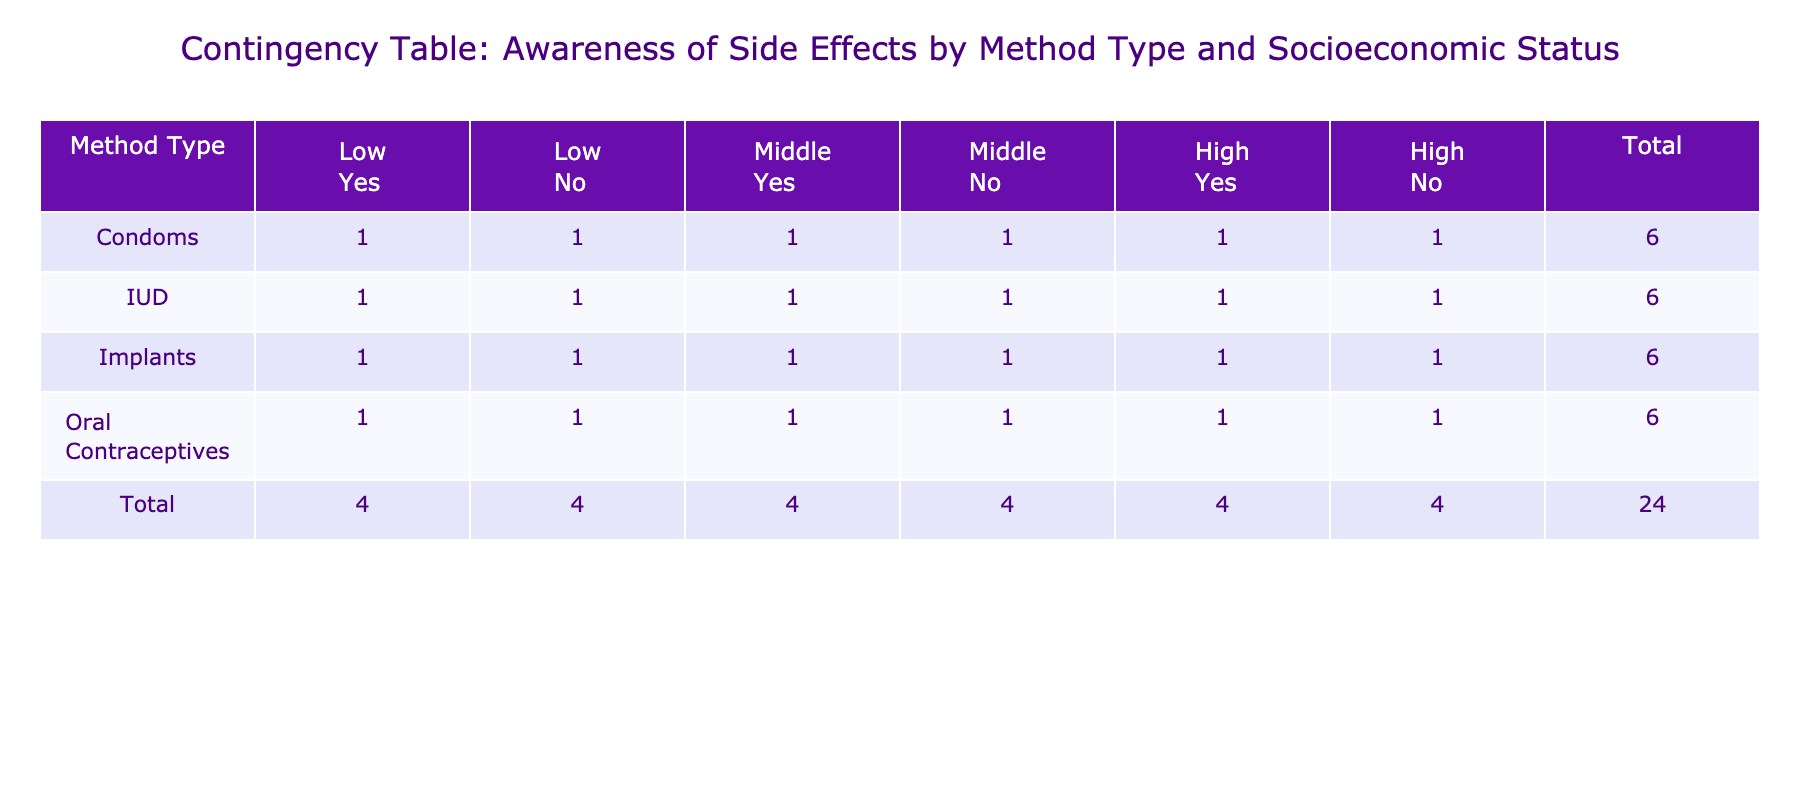What is the total awareness of side effects for Oral Contraceptives among individuals of high socioeconomic status? From the table, we look at the row for 'Oral Contraceptives' and the column 'High' under 'Awareness of Side Effects'. There are 1 person aware of the side effects (Yes) and 1 person not aware (No), so the total awareness (Yes) is 1.
Answer: 1 Which contraception method has the highest number of people aware of the side effects among low socioeconomic status? In the 'Low' socioeconomic status section, we examine the awareness columns for all methods. For 'Oral Contraceptives', 1 is aware; for 'Condoms', also 1 is aware; for 'IUD', 1 person is aware; and for 'Implants', 1 person is aware. All methods have the same total, so they are tied for the highest awareness.
Answer: All methods are tied What is the proportion of people unaware of side effects for Condoms among individuals of middle socioeconomic status? In the middle socioeconomic status for 'Condoms', there is 1 person aware and 1 person unaware of side effects. Total individuals in this category are 2 (1 Yes + 1 No). The proportion is 1 (unaware) divided by 2 (total) which gives us 0.5 or 50%
Answer: 50% How many people in total are aware of side effects for IUD across all socioeconomic statuses? We examine the 'IUD' row. The totals for 'Yes' awareness across all statuses are: 1 (Low Yes) + 1 (Middle Yes) + 1 (High Yes), adding these gives a total of 3 people aware of the side effects for IUD across all socioeconomic statuses.
Answer: 3 Are people of high socioeconomic status more likely to be aware of side effects compared to low socioeconomic status for Implants? For 'Implants', in high socioeconomic status, 1 is aware and 1 is not, totaling 2. In the low socioeconomic status, the situation is the same, with 1 aware and 1 not aware, totaling 2. Therefore, there is no difference in awareness between high and low socioeconomic statuses for Implants.
Answer: No, they have equal awareness What is the total count of individuals using oral contraceptives who are unaware of side effects across all socioeconomic statuses? We analyze the 'Oral Contraceptives' row for the 'No' column. The counts are 1 (Low No), 1 (Middle No), and 1 (High No). Adding these values gives us 3 individuals who are unaware of side effects for oral contraceptives across all statuses.
Answer: 3 How many people in total are there for each method type when considering awareness of side effects for high socioeconomic status? For 'High' socioeconomic status, we sum each method type across the 'Yes' and 'No' columns. For 'Oral Contraceptives' (1 Yes + 1 No = 2), 'Condoms' (1 Yes + 1 No = 2), 'IUD' (1 Yes + 1 No = 2), and 'Implants' (1 Yes + 1 No = 2) each gives a total of 2. Across all methods, the total is 2 + 2 + 2 + 2 = 8.
Answer: 8 